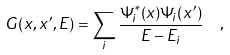Convert formula to latex. <formula><loc_0><loc_0><loc_500><loc_500>G ( x , x ^ { \prime } , E ) = \sum _ { i } \frac { \Psi _ { i } ^ { * } ( x ) \Psi _ { i } ( x ^ { \prime } ) } { E - E _ { i } } \ \ ,</formula> 